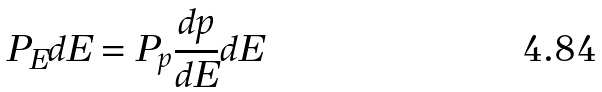Convert formula to latex. <formula><loc_0><loc_0><loc_500><loc_500>P _ { E } d E = P _ { p } \frac { d p } { d E } d E</formula> 